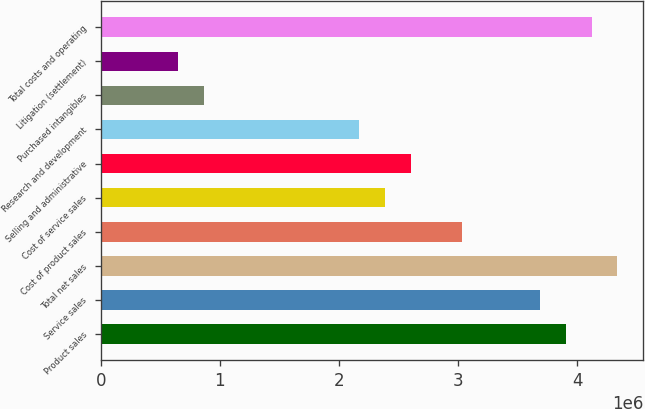Convert chart. <chart><loc_0><loc_0><loc_500><loc_500><bar_chart><fcel>Product sales<fcel>Service sales<fcel>Total net sales<fcel>Cost of product sales<fcel>Cost of service sales<fcel>Selling and administrative<fcel>Research and development<fcel>Purchased intangibles<fcel>Litigation (settlement)<fcel>Total costs and operating<nl><fcel>3.90136e+06<fcel>3.68461e+06<fcel>4.33484e+06<fcel>3.03439e+06<fcel>2.38416e+06<fcel>2.60091e+06<fcel>2.16742e+06<fcel>866973<fcel>650231<fcel>4.1181e+06<nl></chart> 